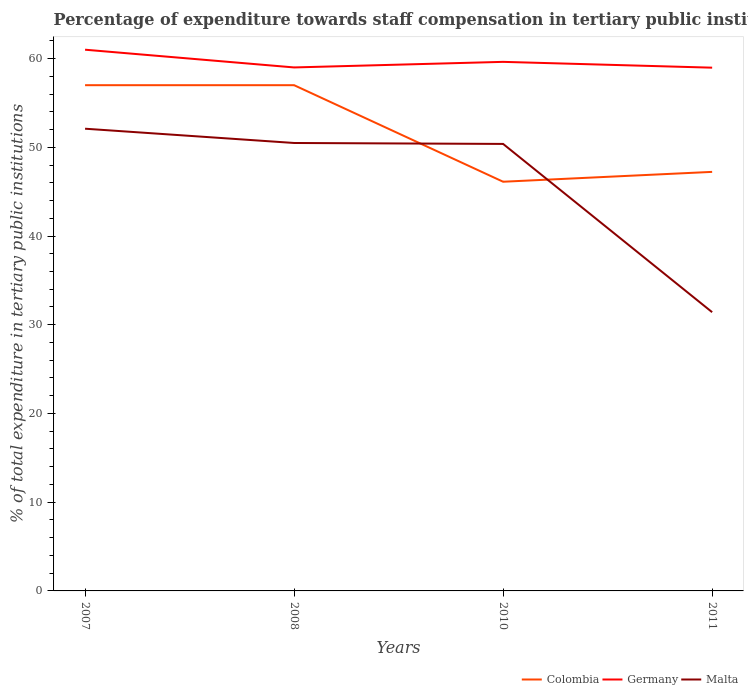Does the line corresponding to Malta intersect with the line corresponding to Germany?
Your answer should be very brief. No. Across all years, what is the maximum percentage of expenditure towards staff compensation in Malta?
Keep it short and to the point. 31.41. In which year was the percentage of expenditure towards staff compensation in Malta maximum?
Make the answer very short. 2011. What is the total percentage of expenditure towards staff compensation in Colombia in the graph?
Your answer should be compact. 9.77. What is the difference between the highest and the second highest percentage of expenditure towards staff compensation in Malta?
Your answer should be very brief. 20.68. What is the difference between the highest and the lowest percentage of expenditure towards staff compensation in Colombia?
Provide a short and direct response. 2. How many lines are there?
Offer a very short reply. 3. How many years are there in the graph?
Offer a terse response. 4. What is the difference between two consecutive major ticks on the Y-axis?
Provide a succinct answer. 10. Does the graph contain any zero values?
Offer a very short reply. No. How many legend labels are there?
Offer a terse response. 3. How are the legend labels stacked?
Make the answer very short. Horizontal. What is the title of the graph?
Make the answer very short. Percentage of expenditure towards staff compensation in tertiary public institutions. What is the label or title of the Y-axis?
Provide a short and direct response. % of total expenditure in tertiary public institutions. What is the % of total expenditure in tertiary public institutions of Colombia in 2007?
Your response must be concise. 57. What is the % of total expenditure in tertiary public institutions in Germany in 2007?
Offer a terse response. 61. What is the % of total expenditure in tertiary public institutions of Malta in 2007?
Provide a succinct answer. 52.09. What is the % of total expenditure in tertiary public institutions in Colombia in 2008?
Your answer should be very brief. 57. What is the % of total expenditure in tertiary public institutions of Germany in 2008?
Make the answer very short. 59. What is the % of total expenditure in tertiary public institutions of Malta in 2008?
Offer a terse response. 50.48. What is the % of total expenditure in tertiary public institutions of Colombia in 2010?
Your response must be concise. 46.12. What is the % of total expenditure in tertiary public institutions of Germany in 2010?
Provide a short and direct response. 59.63. What is the % of total expenditure in tertiary public institutions of Malta in 2010?
Give a very brief answer. 50.38. What is the % of total expenditure in tertiary public institutions of Colombia in 2011?
Provide a succinct answer. 47.23. What is the % of total expenditure in tertiary public institutions in Germany in 2011?
Your response must be concise. 58.97. What is the % of total expenditure in tertiary public institutions in Malta in 2011?
Ensure brevity in your answer.  31.41. Across all years, what is the maximum % of total expenditure in tertiary public institutions of Colombia?
Keep it short and to the point. 57. Across all years, what is the maximum % of total expenditure in tertiary public institutions of Germany?
Your answer should be very brief. 61. Across all years, what is the maximum % of total expenditure in tertiary public institutions of Malta?
Your response must be concise. 52.09. Across all years, what is the minimum % of total expenditure in tertiary public institutions of Colombia?
Make the answer very short. 46.12. Across all years, what is the minimum % of total expenditure in tertiary public institutions in Germany?
Make the answer very short. 58.97. Across all years, what is the minimum % of total expenditure in tertiary public institutions in Malta?
Your answer should be very brief. 31.41. What is the total % of total expenditure in tertiary public institutions in Colombia in the graph?
Provide a short and direct response. 207.34. What is the total % of total expenditure in tertiary public institutions in Germany in the graph?
Your response must be concise. 238.59. What is the total % of total expenditure in tertiary public institutions of Malta in the graph?
Give a very brief answer. 184.37. What is the difference between the % of total expenditure in tertiary public institutions in Germany in 2007 and that in 2008?
Provide a succinct answer. 2. What is the difference between the % of total expenditure in tertiary public institutions of Malta in 2007 and that in 2008?
Your response must be concise. 1.61. What is the difference between the % of total expenditure in tertiary public institutions of Colombia in 2007 and that in 2010?
Your answer should be compact. 10.88. What is the difference between the % of total expenditure in tertiary public institutions in Germany in 2007 and that in 2010?
Your answer should be compact. 1.37. What is the difference between the % of total expenditure in tertiary public institutions in Malta in 2007 and that in 2010?
Provide a succinct answer. 1.72. What is the difference between the % of total expenditure in tertiary public institutions in Colombia in 2007 and that in 2011?
Your answer should be compact. 9.77. What is the difference between the % of total expenditure in tertiary public institutions of Germany in 2007 and that in 2011?
Your response must be concise. 2.03. What is the difference between the % of total expenditure in tertiary public institutions in Malta in 2007 and that in 2011?
Provide a short and direct response. 20.68. What is the difference between the % of total expenditure in tertiary public institutions of Colombia in 2008 and that in 2010?
Your answer should be compact. 10.88. What is the difference between the % of total expenditure in tertiary public institutions in Germany in 2008 and that in 2010?
Make the answer very short. -0.63. What is the difference between the % of total expenditure in tertiary public institutions in Malta in 2008 and that in 2010?
Provide a succinct answer. 0.11. What is the difference between the % of total expenditure in tertiary public institutions in Colombia in 2008 and that in 2011?
Provide a short and direct response. 9.77. What is the difference between the % of total expenditure in tertiary public institutions of Germany in 2008 and that in 2011?
Provide a succinct answer. 0.03. What is the difference between the % of total expenditure in tertiary public institutions of Malta in 2008 and that in 2011?
Offer a terse response. 19.07. What is the difference between the % of total expenditure in tertiary public institutions of Colombia in 2010 and that in 2011?
Ensure brevity in your answer.  -1.11. What is the difference between the % of total expenditure in tertiary public institutions of Germany in 2010 and that in 2011?
Your answer should be very brief. 0.65. What is the difference between the % of total expenditure in tertiary public institutions in Malta in 2010 and that in 2011?
Make the answer very short. 18.96. What is the difference between the % of total expenditure in tertiary public institutions of Colombia in 2007 and the % of total expenditure in tertiary public institutions of Germany in 2008?
Offer a very short reply. -2. What is the difference between the % of total expenditure in tertiary public institutions of Colombia in 2007 and the % of total expenditure in tertiary public institutions of Malta in 2008?
Give a very brief answer. 6.51. What is the difference between the % of total expenditure in tertiary public institutions of Germany in 2007 and the % of total expenditure in tertiary public institutions of Malta in 2008?
Give a very brief answer. 10.51. What is the difference between the % of total expenditure in tertiary public institutions in Colombia in 2007 and the % of total expenditure in tertiary public institutions in Germany in 2010?
Ensure brevity in your answer.  -2.63. What is the difference between the % of total expenditure in tertiary public institutions of Colombia in 2007 and the % of total expenditure in tertiary public institutions of Malta in 2010?
Give a very brief answer. 6.62. What is the difference between the % of total expenditure in tertiary public institutions in Germany in 2007 and the % of total expenditure in tertiary public institutions in Malta in 2010?
Keep it short and to the point. 10.62. What is the difference between the % of total expenditure in tertiary public institutions in Colombia in 2007 and the % of total expenditure in tertiary public institutions in Germany in 2011?
Keep it short and to the point. -1.97. What is the difference between the % of total expenditure in tertiary public institutions of Colombia in 2007 and the % of total expenditure in tertiary public institutions of Malta in 2011?
Your answer should be compact. 25.58. What is the difference between the % of total expenditure in tertiary public institutions of Germany in 2007 and the % of total expenditure in tertiary public institutions of Malta in 2011?
Offer a very short reply. 29.58. What is the difference between the % of total expenditure in tertiary public institutions in Colombia in 2008 and the % of total expenditure in tertiary public institutions in Germany in 2010?
Offer a very short reply. -2.63. What is the difference between the % of total expenditure in tertiary public institutions of Colombia in 2008 and the % of total expenditure in tertiary public institutions of Malta in 2010?
Ensure brevity in your answer.  6.62. What is the difference between the % of total expenditure in tertiary public institutions of Germany in 2008 and the % of total expenditure in tertiary public institutions of Malta in 2010?
Offer a terse response. 8.62. What is the difference between the % of total expenditure in tertiary public institutions of Colombia in 2008 and the % of total expenditure in tertiary public institutions of Germany in 2011?
Ensure brevity in your answer.  -1.97. What is the difference between the % of total expenditure in tertiary public institutions in Colombia in 2008 and the % of total expenditure in tertiary public institutions in Malta in 2011?
Ensure brevity in your answer.  25.58. What is the difference between the % of total expenditure in tertiary public institutions of Germany in 2008 and the % of total expenditure in tertiary public institutions of Malta in 2011?
Your answer should be compact. 27.58. What is the difference between the % of total expenditure in tertiary public institutions in Colombia in 2010 and the % of total expenditure in tertiary public institutions in Germany in 2011?
Keep it short and to the point. -12.86. What is the difference between the % of total expenditure in tertiary public institutions in Colombia in 2010 and the % of total expenditure in tertiary public institutions in Malta in 2011?
Your answer should be very brief. 14.7. What is the difference between the % of total expenditure in tertiary public institutions of Germany in 2010 and the % of total expenditure in tertiary public institutions of Malta in 2011?
Your answer should be compact. 28.21. What is the average % of total expenditure in tertiary public institutions in Colombia per year?
Provide a succinct answer. 51.83. What is the average % of total expenditure in tertiary public institutions in Germany per year?
Give a very brief answer. 59.65. What is the average % of total expenditure in tertiary public institutions of Malta per year?
Your answer should be very brief. 46.09. In the year 2007, what is the difference between the % of total expenditure in tertiary public institutions in Colombia and % of total expenditure in tertiary public institutions in Germany?
Provide a short and direct response. -4. In the year 2007, what is the difference between the % of total expenditure in tertiary public institutions in Colombia and % of total expenditure in tertiary public institutions in Malta?
Your response must be concise. 4.91. In the year 2007, what is the difference between the % of total expenditure in tertiary public institutions of Germany and % of total expenditure in tertiary public institutions of Malta?
Offer a terse response. 8.9. In the year 2008, what is the difference between the % of total expenditure in tertiary public institutions of Colombia and % of total expenditure in tertiary public institutions of Germany?
Provide a succinct answer. -2. In the year 2008, what is the difference between the % of total expenditure in tertiary public institutions of Colombia and % of total expenditure in tertiary public institutions of Malta?
Ensure brevity in your answer.  6.51. In the year 2008, what is the difference between the % of total expenditure in tertiary public institutions in Germany and % of total expenditure in tertiary public institutions in Malta?
Keep it short and to the point. 8.52. In the year 2010, what is the difference between the % of total expenditure in tertiary public institutions in Colombia and % of total expenditure in tertiary public institutions in Germany?
Provide a succinct answer. -13.51. In the year 2010, what is the difference between the % of total expenditure in tertiary public institutions of Colombia and % of total expenditure in tertiary public institutions of Malta?
Your answer should be compact. -4.26. In the year 2010, what is the difference between the % of total expenditure in tertiary public institutions of Germany and % of total expenditure in tertiary public institutions of Malta?
Keep it short and to the point. 9.25. In the year 2011, what is the difference between the % of total expenditure in tertiary public institutions in Colombia and % of total expenditure in tertiary public institutions in Germany?
Offer a very short reply. -11.74. In the year 2011, what is the difference between the % of total expenditure in tertiary public institutions of Colombia and % of total expenditure in tertiary public institutions of Malta?
Keep it short and to the point. 15.81. In the year 2011, what is the difference between the % of total expenditure in tertiary public institutions of Germany and % of total expenditure in tertiary public institutions of Malta?
Your response must be concise. 27.56. What is the ratio of the % of total expenditure in tertiary public institutions in Germany in 2007 to that in 2008?
Make the answer very short. 1.03. What is the ratio of the % of total expenditure in tertiary public institutions in Malta in 2007 to that in 2008?
Give a very brief answer. 1.03. What is the ratio of the % of total expenditure in tertiary public institutions in Colombia in 2007 to that in 2010?
Offer a very short reply. 1.24. What is the ratio of the % of total expenditure in tertiary public institutions in Germany in 2007 to that in 2010?
Provide a succinct answer. 1.02. What is the ratio of the % of total expenditure in tertiary public institutions in Malta in 2007 to that in 2010?
Your answer should be compact. 1.03. What is the ratio of the % of total expenditure in tertiary public institutions of Colombia in 2007 to that in 2011?
Offer a terse response. 1.21. What is the ratio of the % of total expenditure in tertiary public institutions of Germany in 2007 to that in 2011?
Give a very brief answer. 1.03. What is the ratio of the % of total expenditure in tertiary public institutions in Malta in 2007 to that in 2011?
Make the answer very short. 1.66. What is the ratio of the % of total expenditure in tertiary public institutions in Colombia in 2008 to that in 2010?
Offer a terse response. 1.24. What is the ratio of the % of total expenditure in tertiary public institutions of Germany in 2008 to that in 2010?
Give a very brief answer. 0.99. What is the ratio of the % of total expenditure in tertiary public institutions of Malta in 2008 to that in 2010?
Make the answer very short. 1. What is the ratio of the % of total expenditure in tertiary public institutions in Colombia in 2008 to that in 2011?
Keep it short and to the point. 1.21. What is the ratio of the % of total expenditure in tertiary public institutions in Germany in 2008 to that in 2011?
Your answer should be compact. 1. What is the ratio of the % of total expenditure in tertiary public institutions of Malta in 2008 to that in 2011?
Offer a terse response. 1.61. What is the ratio of the % of total expenditure in tertiary public institutions of Colombia in 2010 to that in 2011?
Your response must be concise. 0.98. What is the ratio of the % of total expenditure in tertiary public institutions in Germany in 2010 to that in 2011?
Offer a terse response. 1.01. What is the ratio of the % of total expenditure in tertiary public institutions in Malta in 2010 to that in 2011?
Offer a terse response. 1.6. What is the difference between the highest and the second highest % of total expenditure in tertiary public institutions in Germany?
Give a very brief answer. 1.37. What is the difference between the highest and the second highest % of total expenditure in tertiary public institutions of Malta?
Provide a succinct answer. 1.61. What is the difference between the highest and the lowest % of total expenditure in tertiary public institutions in Colombia?
Your response must be concise. 10.88. What is the difference between the highest and the lowest % of total expenditure in tertiary public institutions in Germany?
Provide a succinct answer. 2.03. What is the difference between the highest and the lowest % of total expenditure in tertiary public institutions in Malta?
Offer a terse response. 20.68. 